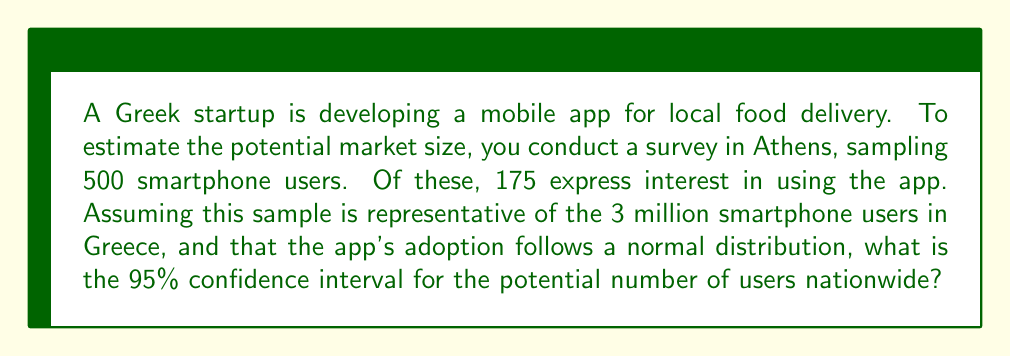Provide a solution to this math problem. Let's approach this step-by-step:

1) First, we calculate the sample proportion:
   $p = \frac{175}{500} = 0.35$ or 35%

2) The standard error of the proportion is given by:
   $SE = \sqrt{\frac{p(1-p)}{n}} = \sqrt{\frac{0.35(1-0.35)}{500}} = 0.0213$

3) For a 95% confidence interval, we use a z-score of 1.96.

4) The confidence interval for the proportion is:
   $p \pm 1.96 * SE = 0.35 \pm 1.96 * 0.0213 = [0.3083, 0.3917]$

5) To estimate the number of users nationwide, we multiply these proportions by the total number of smartphone users in Greece (3 million):

   Lower bound: $3,000,000 * 0.3083 = 924,900$
   Upper bound: $3,000,000 * 0.3917 = 1,175,100$

Therefore, the 95% confidence interval for the potential number of users nationwide is [924,900, 1,175,100].

6) The interval can be expressed mathematically as:

   $$[3,000,000 * (p - 1.96 * SE), 3,000,000 * (p + 1.96 * SE)]$$

   where $p = 0.35$ and $SE = 0.0213$
Answer: [924,900, 1,175,100] 